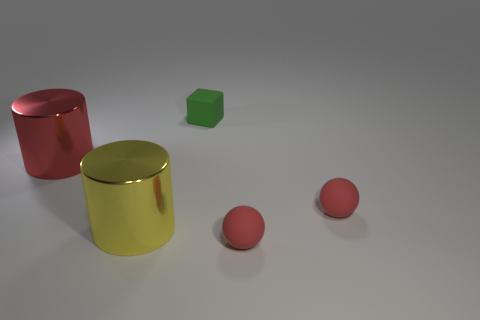Add 4 tiny red metallic spheres. How many objects exist? 9 Subtract all blocks. How many objects are left? 4 Add 3 tiny red rubber spheres. How many tiny red rubber spheres are left? 5 Add 4 tiny green matte blocks. How many tiny green matte blocks exist? 5 Subtract 0 brown spheres. How many objects are left? 5 Subtract all blue metal balls. Subtract all tiny red spheres. How many objects are left? 3 